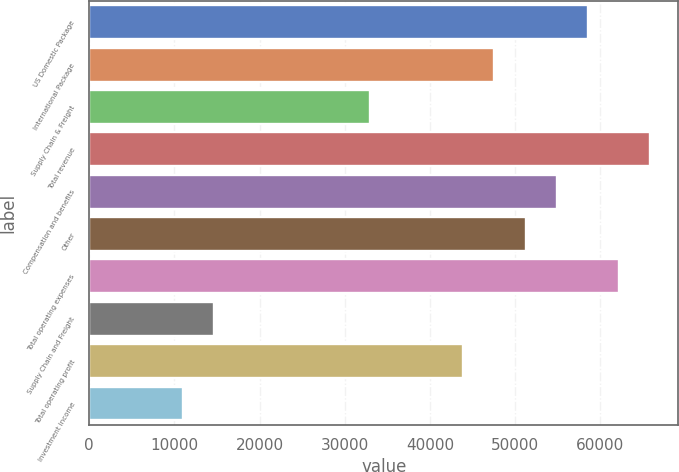Convert chart to OTSL. <chart><loc_0><loc_0><loc_500><loc_500><bar_chart><fcel>US Domestic Package<fcel>International Package<fcel>Supply Chain & Freight<fcel>Total revenue<fcel>Compensation and benefits<fcel>Other<fcel>Total operating expenses<fcel>Supply Chain and Freight<fcel>Total operating profit<fcel>Investment income<nl><fcel>58530.6<fcel>47556.3<fcel>32923.9<fcel>65846.7<fcel>54872.5<fcel>51214.4<fcel>62188.7<fcel>14633.5<fcel>43898.2<fcel>10975.4<nl></chart> 